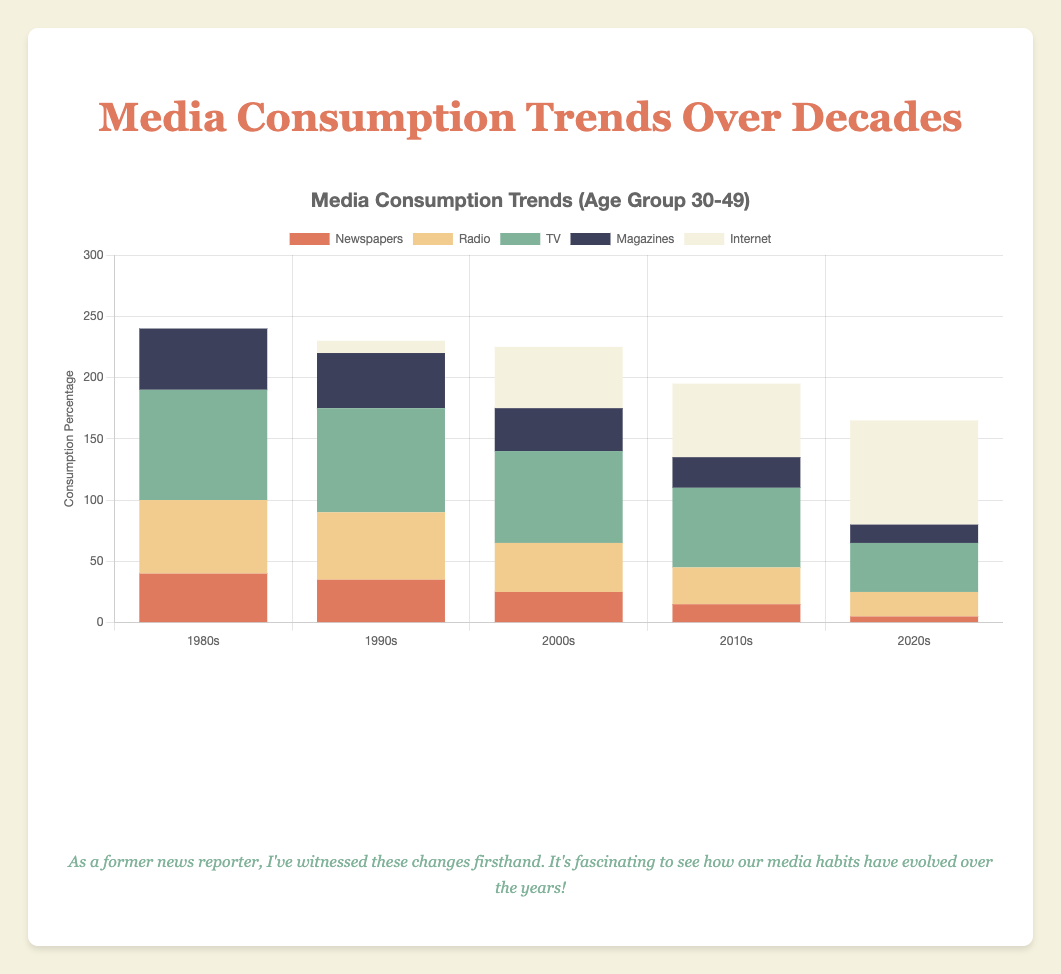what is the total media consumption percentage for TV in the 1980s for all age groups? In the 1980s, the TV consumption percentages are 80 (age 18-29), 90 (age 30-49), and 95 (age 50+). Summing them up gives 80 + 90 + 95 = 265.
Answer: 265 Which type of media saw the most significant increase from the 1980s to the 2020s for the age group 18-29? For age group 18-29, internet usage increased from 0% in the 1980s to 90% in the 2020s. This is the most significant increase among all media types.
Answer: Internet Did the radio consumption percentage for the age group 50+ increase or decrease from the 1990s to the 2020s, and by how much? In the 1990s, radio consumption for age group 50+ was 65%, and in the 2020s, it was 30%. The decrease is 65 - 30 = 35%.
Answer: Decrease by 35% What decade shows the highest internet consumption for the age group 30-49? By looking at the bars representing internet consumption for age group 30-49, the highest bar is in the 2020s with 85%.
Answer: 2020s Which media type had the highest consumption percentage in the 2000s for the age group 30-49? For the age group 30-49 in the 2000s, TV had the highest consumption at 75%.
Answer: TV What is the difference in magazine consumption between the 1980s and 2020s for the age group 50+? In the 1980s, the magazine consumption for age group 50+ was 60%, and in the 2020s, it was 20%. The difference is 60 - 20 = 40%.
Answer: 40% Which age group had the highest radio consumption in the 1980s? In the 1980s, the radio consumption for age groups 18-29, 30-49, and 50+ were 50%, 60%, and 70% respectively. The highest consumption was by the age group 50+.
Answer: Age group 50+ What is the sum of the percentages for all media types in the 2020s for the age group 18-29? Adding up the percentages for newspapers (2), radio (10), TV (30), magazines (10), and internet (90) in the 2020s for age group 18-29: 2 + 10 + 30 + 10 + 90 = 142.
Answer: 142 Among age groups, which group has the highest TV consumption in the 2010s? In the 2010s, the TV consumption percentages for age groups 18-29, 30-49, and 50+ were 50%, 65%, and 70% respectively. The highest was by age group 50+.
Answer: Age group 50+ How did TV consumption change for the age group 18-29 from the 1980s to the 2010s? In the 1980s, TV consumption was 80%, while in the 2010s, it was 50%. The change is 80 - 50 = 30% decrease.
Answer: Decrease by 30% 